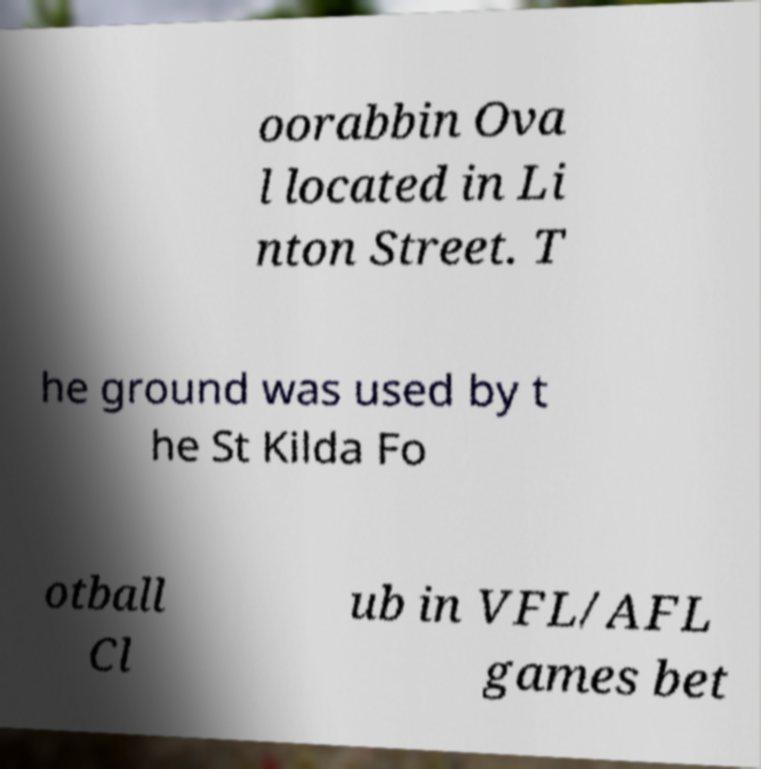Could you extract and type out the text from this image? oorabbin Ova l located in Li nton Street. T he ground was used by t he St Kilda Fo otball Cl ub in VFL/AFL games bet 